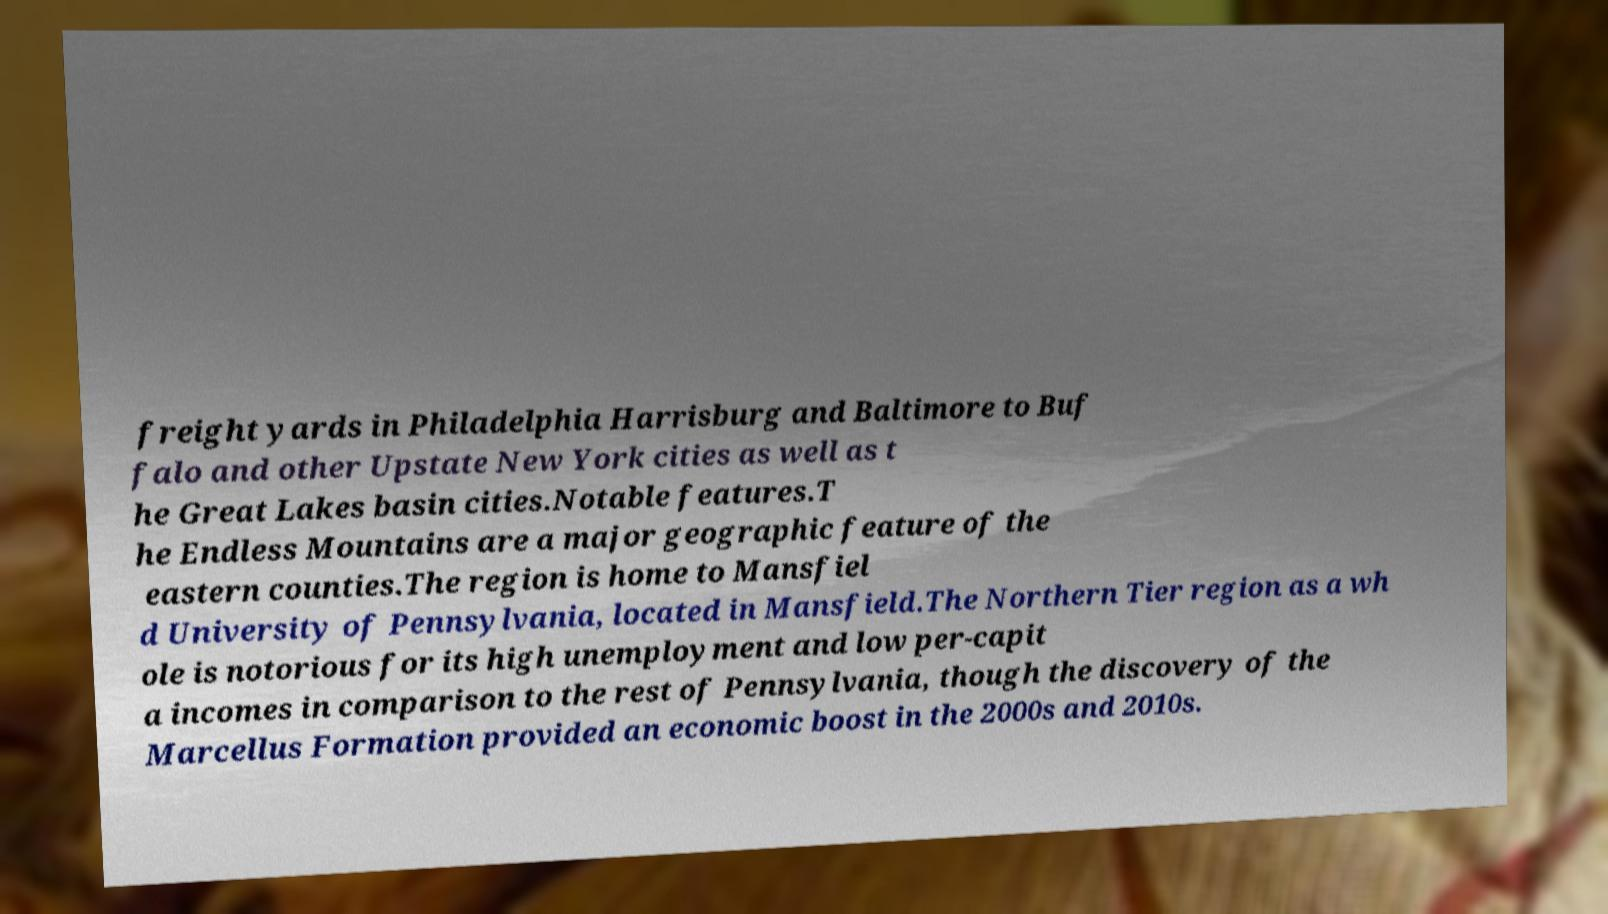Could you extract and type out the text from this image? freight yards in Philadelphia Harrisburg and Baltimore to Buf falo and other Upstate New York cities as well as t he Great Lakes basin cities.Notable features.T he Endless Mountains are a major geographic feature of the eastern counties.The region is home to Mansfiel d University of Pennsylvania, located in Mansfield.The Northern Tier region as a wh ole is notorious for its high unemployment and low per-capit a incomes in comparison to the rest of Pennsylvania, though the discovery of the Marcellus Formation provided an economic boost in the 2000s and 2010s. 